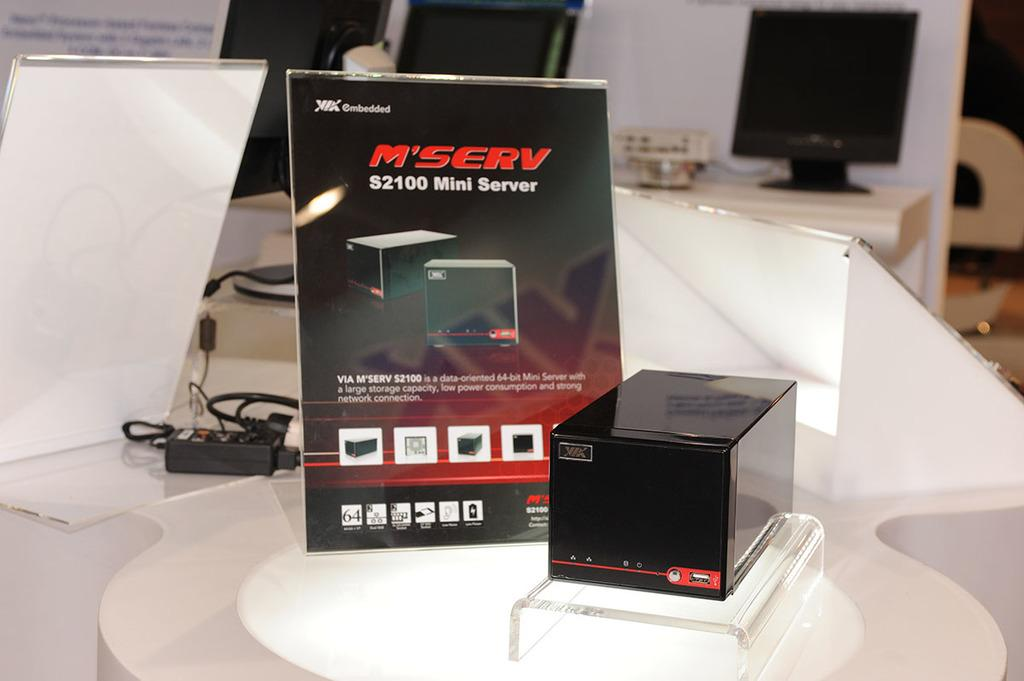Provide a one-sentence caption for the provided image. black box called serv and the display sign. 